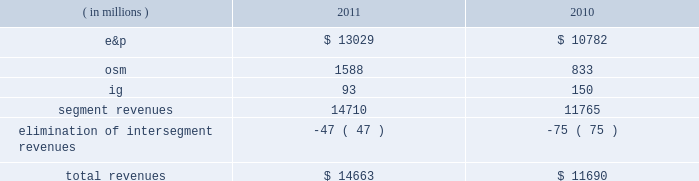2022 increased proved liquid hydrocarbon , including synthetic crude oil , reserves to 78 percent from 75 percent of proved reserves 2022 increased e&p net sales volumes , excluding libya , by 7 percent 2022 recorded 96 percent average operational availability for all major company-operated e&p assets , compared to 94 percent in 2010 2022 completed debottlenecking work that increased crude oil production capacity at the alvheim fpso in norway to 150000 gross bbld from the previous capacity of 142000 gross bbld and the original 2008 capacity of 120000 gross bbld 2022 announced two non-operated discoveries in the iraqi kurdistan region and began drilling in poland 2022 completed aosp expansion 1 , including the start-up of the expanded scotford upgrader , realizing an increase in net synthetic crude oil sales volumes of 48 percent 2022 completed dispositions of non-core assets and interests in acreage positions for net proceeds of $ 518 million 2022 repurchased 12 million shares of our common stock at a cost of $ 300 million 2022 retired $ 2498 million principal of our long-term debt 2022 resumed limited production in libya in the fourth quarter of 2011 following the february 2011 temporary suspension of operations consolidated results of operations : 2011 compared to 2010 due to the spin-off of our downstream business on june 30 , 2011 , which is reported as discontinued operations , income from continuing operations is more representative of marathon oil as an independent energy company .
Consolidated income from continuing operations before income taxes was 9 percent higher in 2011 than in 2010 , largely due to higher liquid hydrocarbon prices .
This improvement was offset by increased income taxes primarily the result of excess foreign tax credits generated during 2011 that we do not expect to utilize in the future .
The effective income tax rate for continuing operations was 61 percent in 2011 compared to 54 percent in 2010 .
Revenues are summarized in the table : ( in millions ) 2011 2010 .
E&p segment revenues increased $ 2247 million from 2010 to 2011 , primarily due to higher average liquid hydrocarbon realizations , which were $ 99.37 per bbl in 2011 , a 31 percent increase over 2010 .
Revenues in 2010 included net pre-tax gains of $ 95 million on derivative instruments intended to mitigate price risk on future sales of liquid hydrocarbons and natural gas .
Included in our e&p segment are supply optimization activities which include the purchase of commodities from third parties for resale .
Supply optimization serves to aggregate volumes in order to satisfy transportation commitments and to achieve flexibility within product types and delivery points .
See the cost of revenues discussion as revenues from supply optimization approximate the related costs .
Higher average crude oil prices in 2011 compared to 2010 increased revenues related to supply optimization .
Revenues from the sale of our u.s .
Production are higher in 2011 primarily as a result of higher liquid hydrocarbon and natural gas price realizations , but sales volumes declined. .
By how much did total revenues increase from 2010 to 2011? 
Computations: ((14663 - 11690) / 11690)
Answer: 0.25432. 